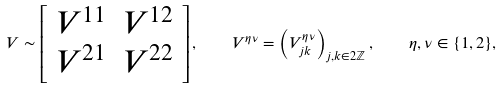Convert formula to latex. <formula><loc_0><loc_0><loc_500><loc_500>V \sim \left [ \begin{array} { c c } V ^ { 1 1 } & V ^ { 1 2 } \\ V ^ { 2 1 } & V ^ { 2 2 } \end{array} \right ] , \quad V ^ { \eta \nu } = \left ( V ^ { \eta \nu } _ { j k } \right ) _ { j , k \in 2 \mathbb { Z } } , \quad \eta , \nu \in \{ 1 , 2 \} ,</formula> 